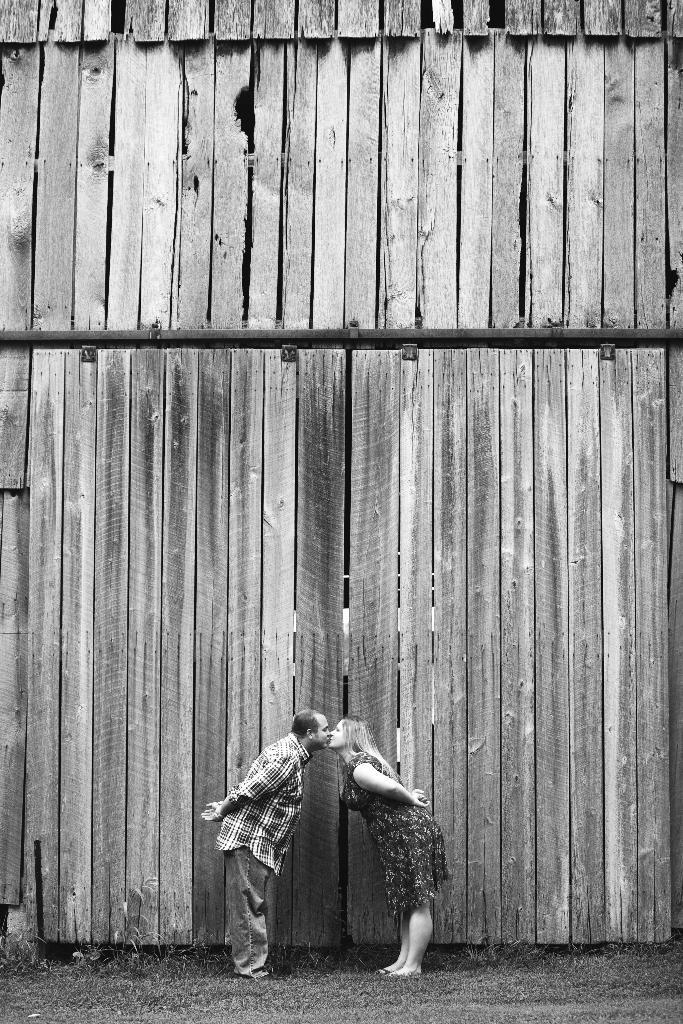How many people are present in the image? There are two people, a man and a woman, present in the image. What are the man and woman doing in the image? The man and woman are kissing in the image. What is the position of the man and woman in the image? The man and woman are slightly bending in the image. Where is the scene taking place? The scene is on the grass on the ground. What type of structure is visible in the image? There is a wooden wall in the image. How many cubs are playing with the wooden wall in the image? There are no cubs present in the image, and therefore no such activity can be observed. 